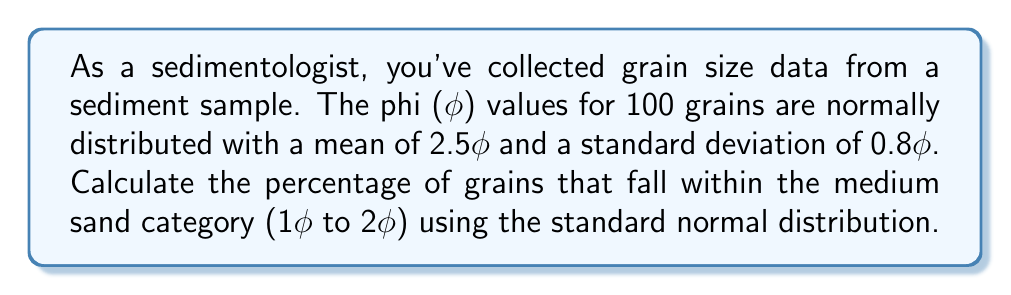Solve this math problem. To solve this problem, we'll follow these steps:

1) First, we need to standardize the phi values that define the medium sand category:

   For 1φ: $z_1 = \frac{1 - 2.5}{0.8} = -1.875$
   For 2φ: $z_2 = \frac{2 - 2.5}{0.8} = -0.625$

2) Now, we need to find the area under the standard normal curve between these z-scores. This represents the proportion of grains in the medium sand category.

3) Using a standard normal distribution table or calculator:
   
   $P(z < -0.625) = 0.2660$
   $P(z < -1.875) = 0.0304$

4) The area we're looking for is the difference between these probabilities:

   $P(-1.875 < z < -0.625) = 0.2660 - 0.0304 = 0.2356$

5) To express this as a percentage, we multiply by 100:

   $0.2356 * 100 = 23.56\%$

Therefore, approximately 23.56% of the grains fall within the medium sand category.
Answer: 23.56% 